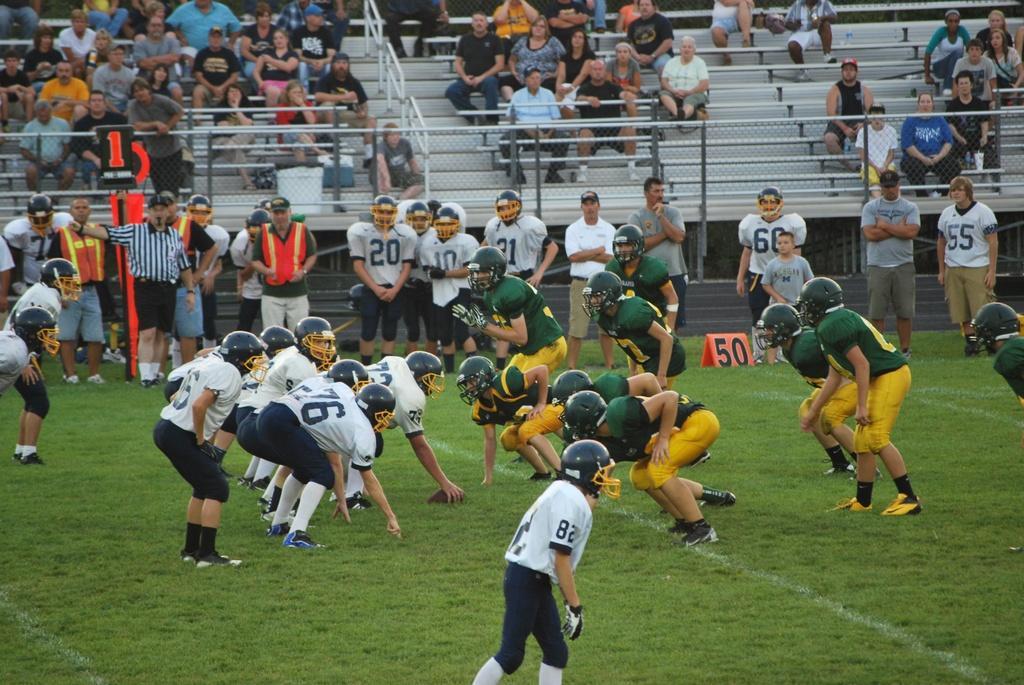Please provide a concise description of this image. In this picture there are two teams who are wearing green and yellow dress and the other team is wearing white and black dress. On the left there is an umpire who is holding a card, beside him we can see the substitute players were standing on the grass. At the top i can see many people were standing and sitting on the stairs. Beside them i can see the fencing. 